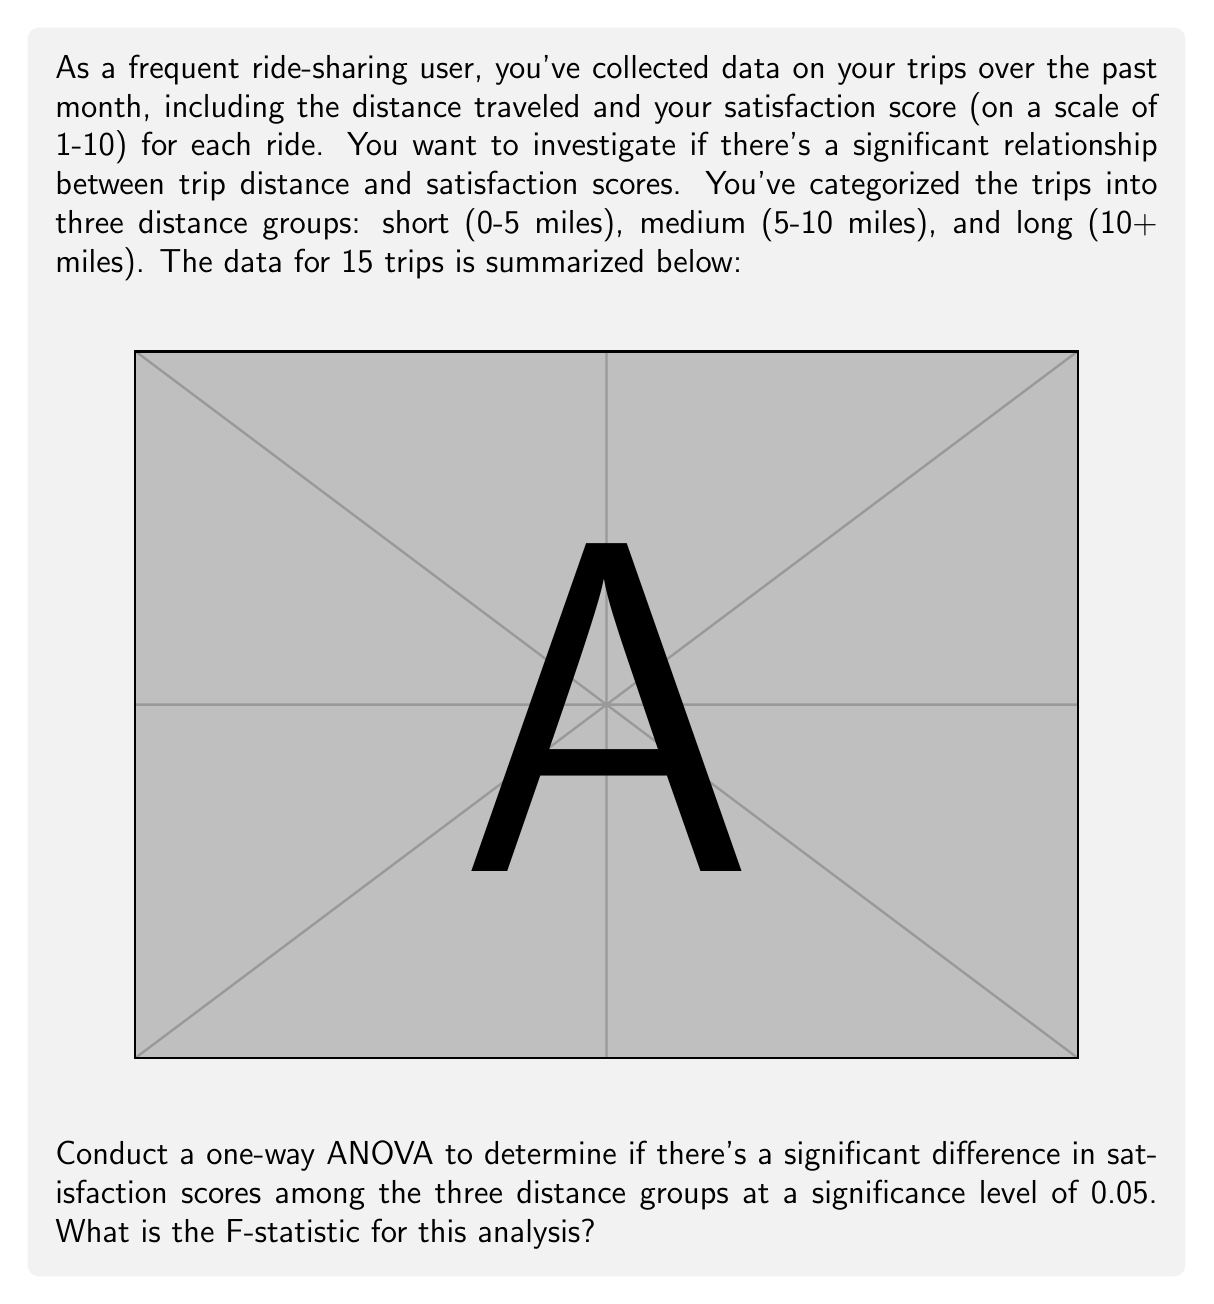Show me your answer to this math problem. To conduct a one-way ANOVA, we'll follow these steps:

1. Calculate the mean satisfaction score for each group:
   Short: $\bar{X}_S = (8 + 7 + 9 + 8 + 7) / 5 = 7.8$
   Medium: $\bar{X}_M = (6 + 7 + 5 + 8 + 6) / 5 = 6.4$
   Long: $\bar{X}_L = (4 + 5 + 6 + 3 + 5) / 5 = 4.6$

2. Calculate the grand mean:
   $\bar{X} = (7.8 + 6.4 + 4.6) / 3 = 6.27$

3. Calculate the Sum of Squares Between (SSB):
   $$SSB = 5[(7.8 - 6.27)^2 + (6.4 - 6.27)^2 + (4.6 - 6.27)^2] = 24.13$$

4. Calculate the Sum of Squares Within (SSW):
   Short: $\sum(X - 7.8)^2 = 0.2 + 0.8 + 1.2 + 0.2 + 0.8 = 3.2$
   Medium: $\sum(X - 6.4)^2 = 0.16 + 0.36 + 1.96 + 2.56 + 0.16 = 5.2$
   Long: $\sum(X - 4.6)^2 = 0.36 + 0.16 + 1.96 + 2.56 + 0.16 = 5.2$
   $$SSW = 3.2 + 5.2 + 5.2 = 13.6$$

5. Calculate degrees of freedom:
   Between groups: $df_B = 3 - 1 = 2$
   Within groups: $df_W = 15 - 3 = 12$

6. Calculate Mean Square Between (MSB) and Mean Square Within (MSW):
   $$MSB = SSB / df_B = 24.13 / 2 = 12.065$$
   $$MSW = SSW / df_W = 13.6 / 12 = 1.133$$

7. Calculate the F-statistic:
   $$F = MSB / MSW = 12.065 / 1.133 = 10.65$$
Answer: 10.65 